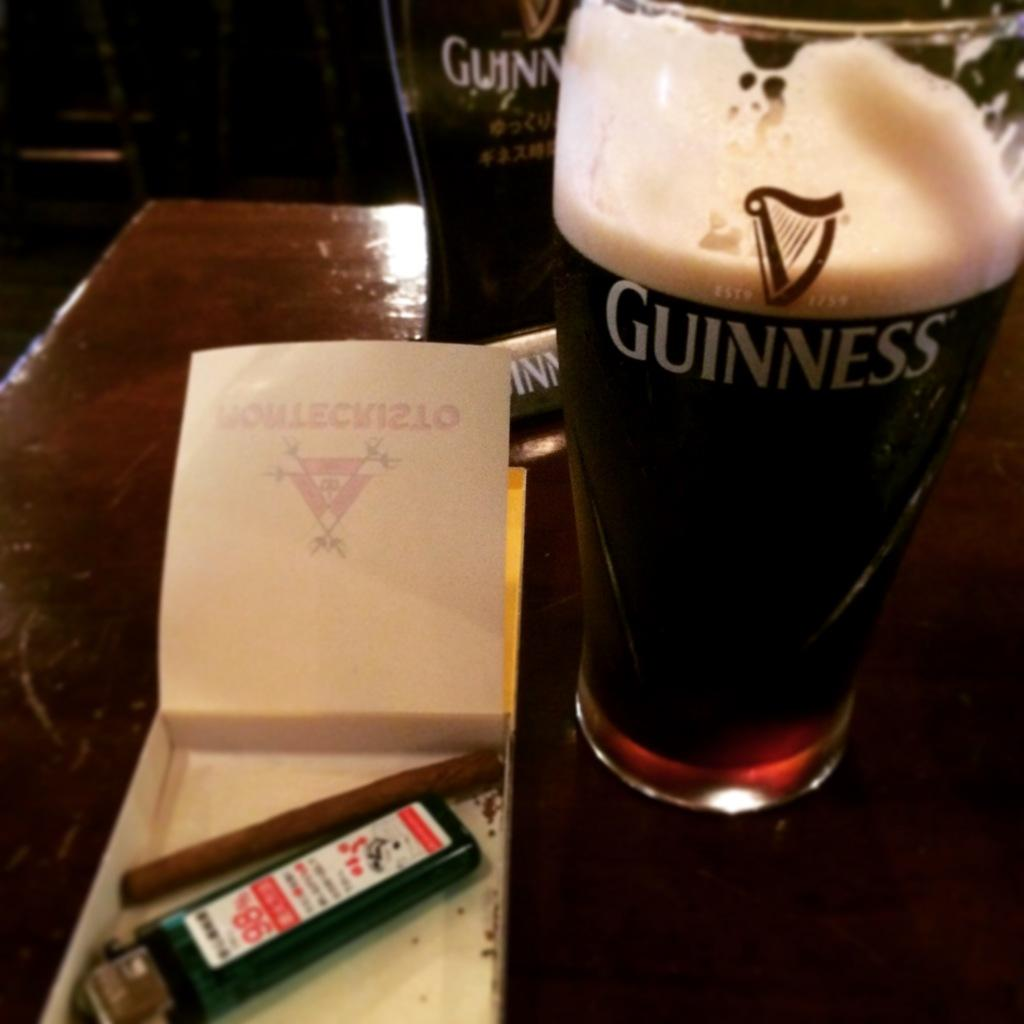What piece of furniture is present in the image? There is a table in the image. What objects are placed on the table? There are glasses, a box, a paper, and a remote on the table. How many members are on the team that is visible in the image? There is no team present in the image; it only features a table with various objects on it. 